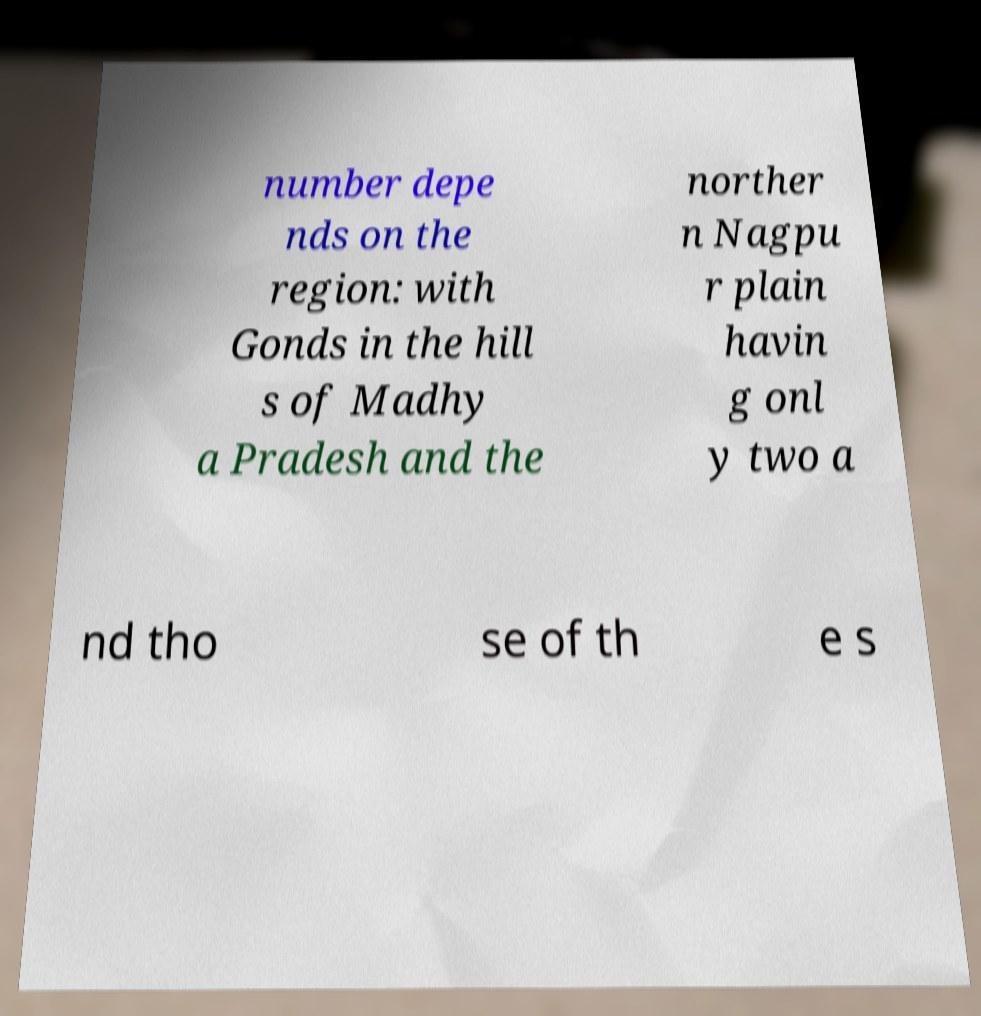Can you read and provide the text displayed in the image?This photo seems to have some interesting text. Can you extract and type it out for me? number depe nds on the region: with Gonds in the hill s of Madhy a Pradesh and the norther n Nagpu r plain havin g onl y two a nd tho se of th e s 